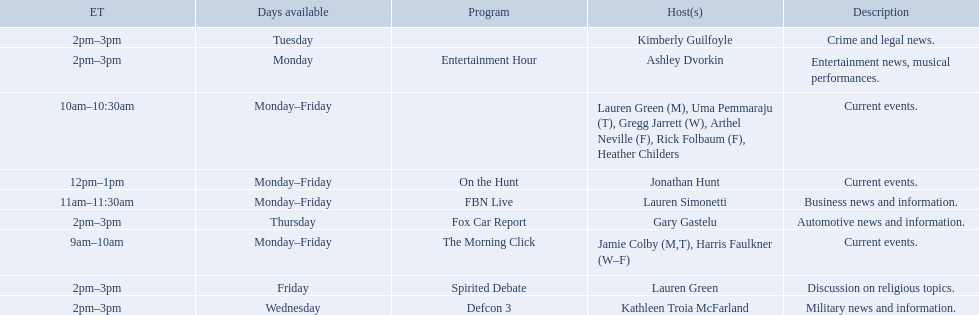What is the duration of on the hunt? 1 hour. 